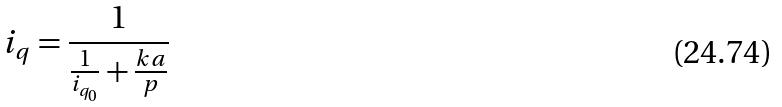Convert formula to latex. <formula><loc_0><loc_0><loc_500><loc_500>i _ { q } = \frac { 1 } { \frac { 1 } { i _ { q _ { 0 } } } + \frac { k a } { p } }</formula> 